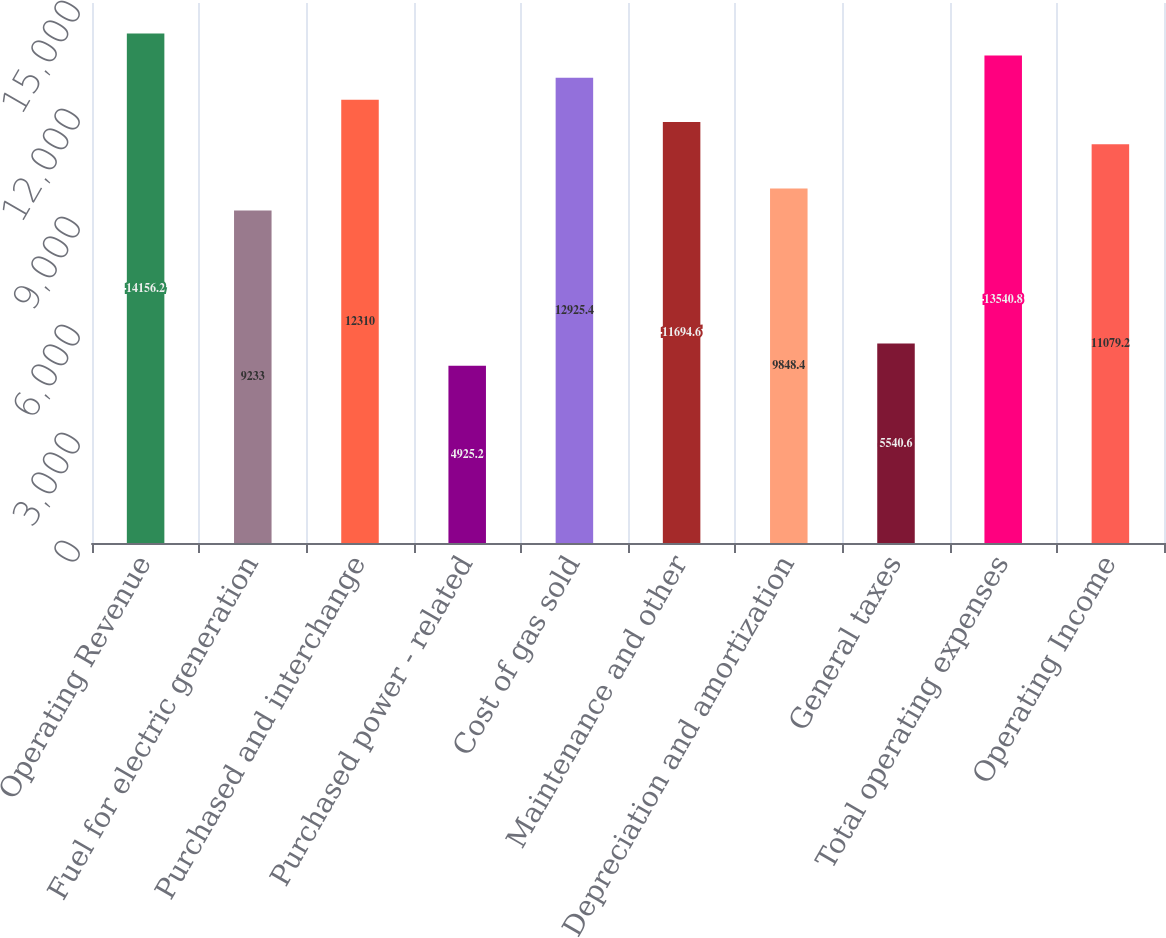Convert chart to OTSL. <chart><loc_0><loc_0><loc_500><loc_500><bar_chart><fcel>Operating Revenue<fcel>Fuel for electric generation<fcel>Purchased and interchange<fcel>Purchased power - related<fcel>Cost of gas sold<fcel>Maintenance and other<fcel>Depreciation and amortization<fcel>General taxes<fcel>Total operating expenses<fcel>Operating Income<nl><fcel>14156.2<fcel>9233<fcel>12310<fcel>4925.2<fcel>12925.4<fcel>11694.6<fcel>9848.4<fcel>5540.6<fcel>13540.8<fcel>11079.2<nl></chart> 